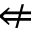<formula> <loc_0><loc_0><loc_500><loc_500>\ n L e f t a r r o w</formula> 